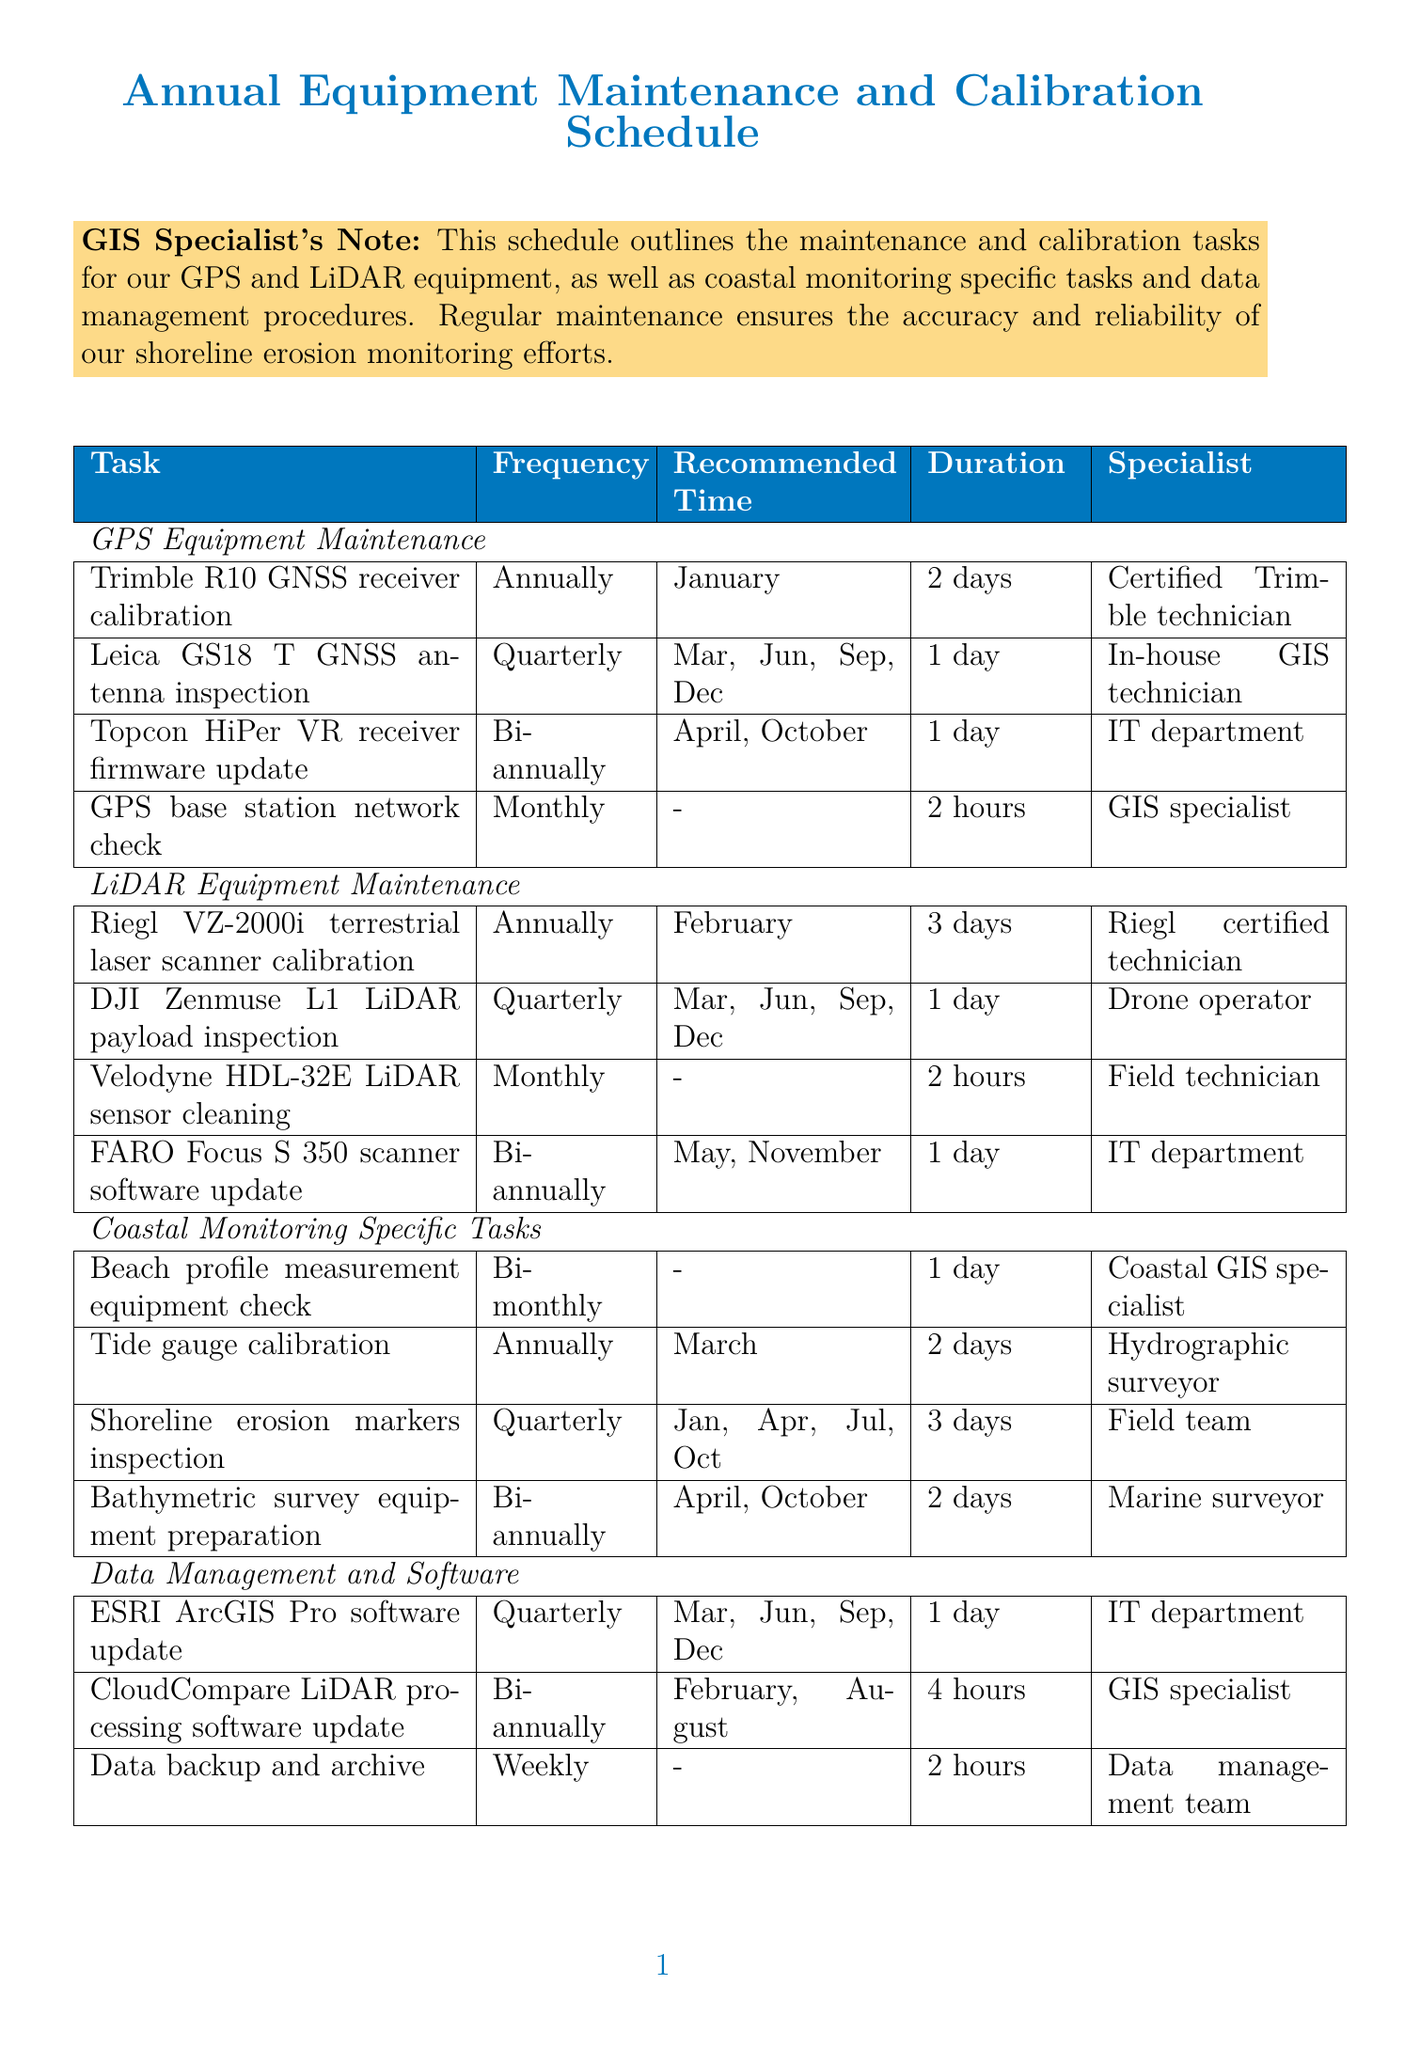what is the duration of the Trimble R10 GNSS receiver calibration? The duration for this task is specified in the schedule, which is 2 days.
Answer: 2 days how often is the Leica GS18 T GNSS antenna inspected? The frequency for the inspection of this antenna is mentioned as Quarterly.
Answer: Quarterly who performs the Tide gauge calibration? The document indicates that a Hydrographic surveyor is responsible for this task.
Answer: Hydrographic surveyor how many days is allocated for the Riegl VZ-2000i terrestrial laser scanner calibration? The schedule states that the calibration takes 3 days to complete.
Answer: 3 days when is the CloudCompare LiDAR processing software updated? The recommended months for this update are specified as February and August.
Answer: February, August what is the frequency of the GPS base station network check? The frequency for this check is listed as Monthly in the document.
Answer: Monthly how many specialists are involved in the annual equipment maintenance tasks listed? There are four different specialists mentioned across the various maintenance tasks in the document.
Answer: Four how long does the shoreline change analysis algorithm review take? According to the schedule, this review is expected to take 1 week.
Answer: 1 week what is the recommended time for the FARO Focus S 350 scanner software update? This update is scheduled for the months of May and November, as stated in the document.
Answer: May, November 